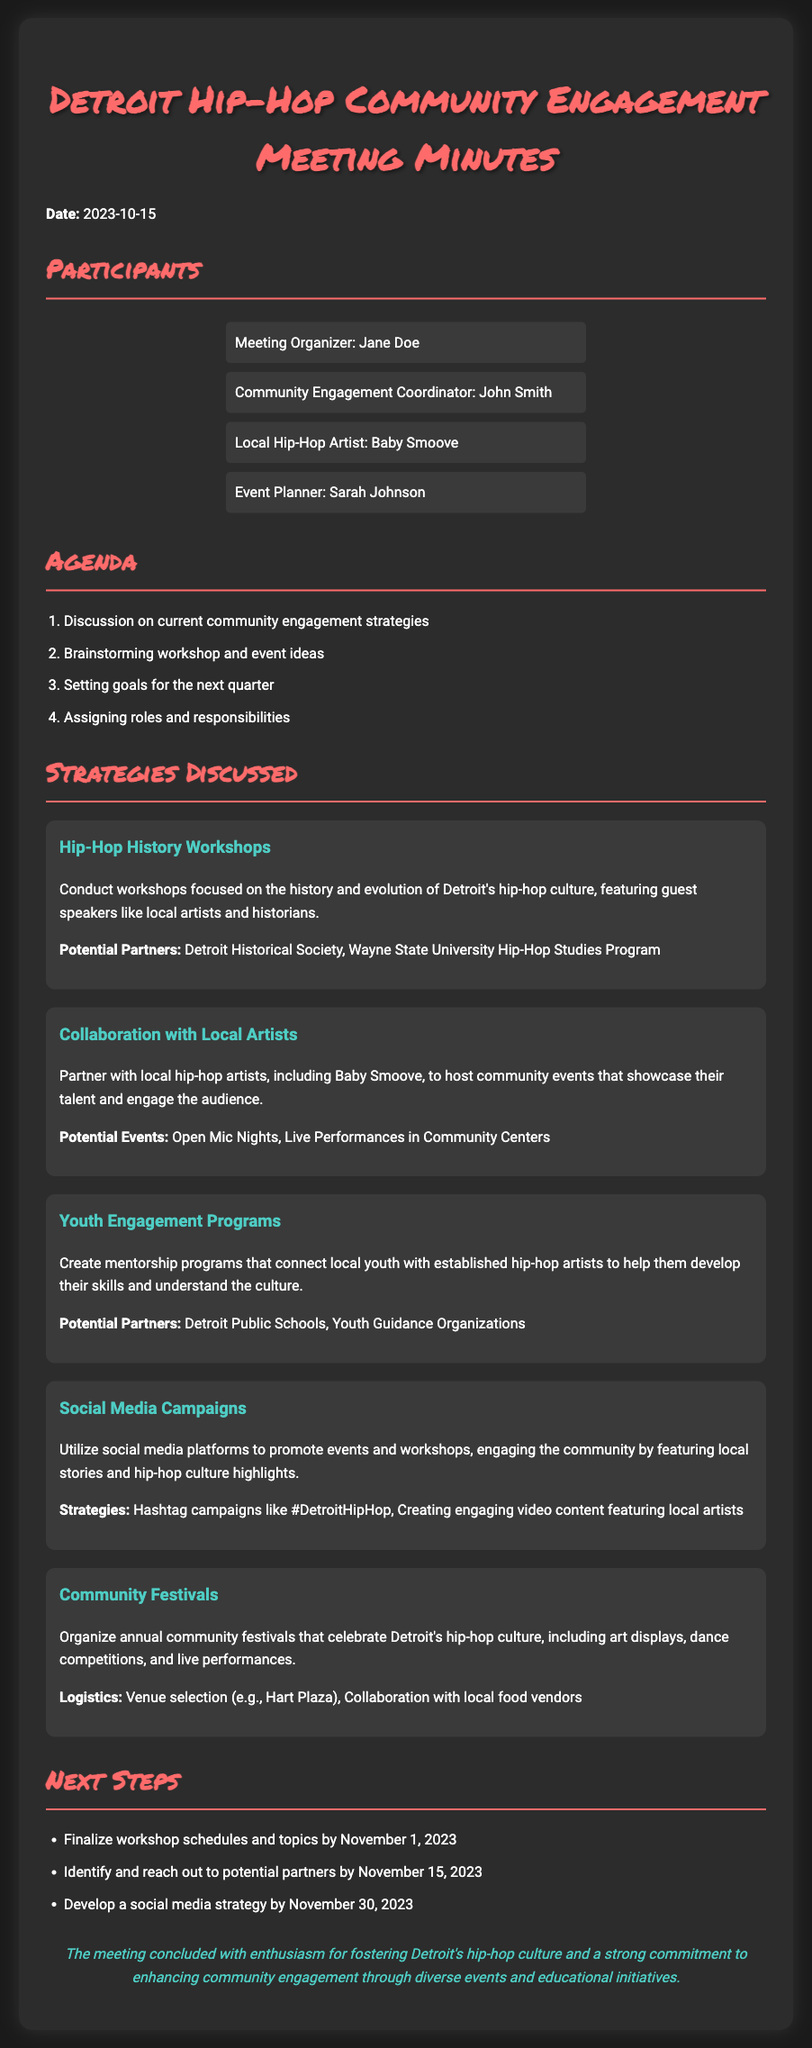What is the date of the meeting? The date of the meeting is explicitly mentioned in the document.
Answer: 2023-10-15 Who is the local hip-hop artist mentioned? The local hip-hop artist is listed among the participants of the meeting.
Answer: Baby Smoove What is one type of workshop discussed? The document lists different strategies, including specific workshops focused on hip-hop culture.
Answer: Hip-Hop History Workshops What is the goal for finalizing workshop schedules? The document specifies a deadline for workshop schedules and topics.
Answer: November 1, 2023 What type of social media strategy is intended? The document outlines plans to promote events and engage the community on social media.
Answer: Hashtag campaigns like #DetroitHipHop Which venue is suggested for community festivals? The document mentions a venue option for the community festivals.
Answer: Hart Plaza What is one organization mentioned as a potential partner for youth engagement? The document includes potential partners for various strategies.
Answer: Detroit Public Schools What has been established as a focus for the next quarter? The document indicates specific areas of focus for the upcoming quarter.
Answer: Community engagement What is the color used for headings in this document? The visual presentation of the document specifies a distinct color for headings.
Answer: #ff6b6b 